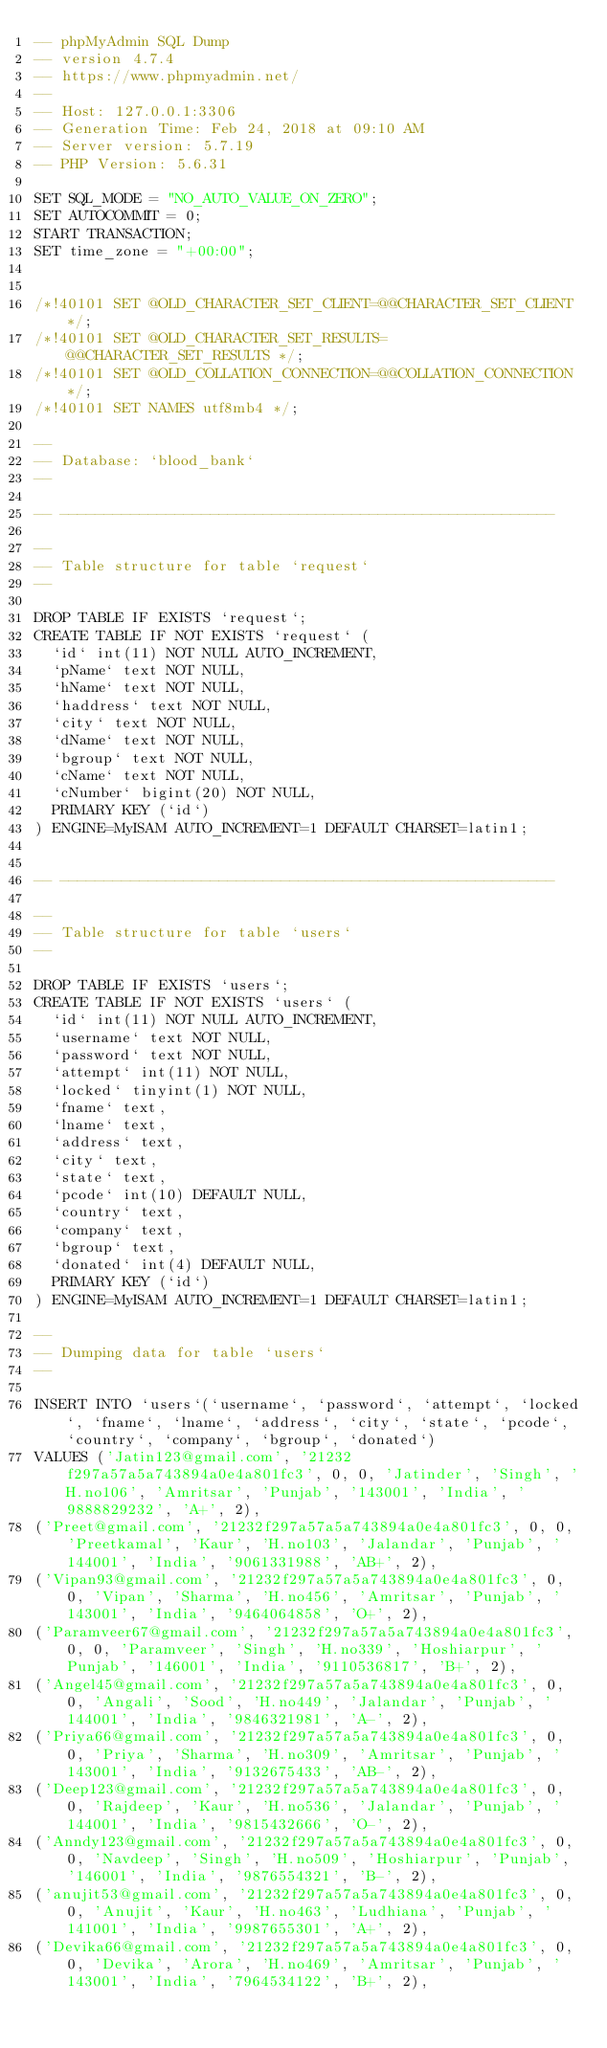<code> <loc_0><loc_0><loc_500><loc_500><_SQL_>-- phpMyAdmin SQL Dump
-- version 4.7.4
-- https://www.phpmyadmin.net/
--
-- Host: 127.0.0.1:3306
-- Generation Time: Feb 24, 2018 at 09:10 AM
-- Server version: 5.7.19
-- PHP Version: 5.6.31

SET SQL_MODE = "NO_AUTO_VALUE_ON_ZERO";
SET AUTOCOMMIT = 0;
START TRANSACTION;
SET time_zone = "+00:00";


/*!40101 SET @OLD_CHARACTER_SET_CLIENT=@@CHARACTER_SET_CLIENT */;
/*!40101 SET @OLD_CHARACTER_SET_RESULTS=@@CHARACTER_SET_RESULTS */;
/*!40101 SET @OLD_COLLATION_CONNECTION=@@COLLATION_CONNECTION */;
/*!40101 SET NAMES utf8mb4 */;

--
-- Database: `blood_bank`
--

-- --------------------------------------------------------

--
-- Table structure for table `request`
--

DROP TABLE IF EXISTS `request`;
CREATE TABLE IF NOT EXISTS `request` (
  `id` int(11) NOT NULL AUTO_INCREMENT,
  `pName` text NOT NULL,
  `hName` text NOT NULL,
  `haddress` text NOT NULL,
  `city` text NOT NULL,
  `dName` text NOT NULL,
  `bgroup` text NOT NULL,
  `cName` text NOT NULL,
  `cNumber` bigint(20) NOT NULL,
  PRIMARY KEY (`id`)
) ENGINE=MyISAM AUTO_INCREMENT=1 DEFAULT CHARSET=latin1;


-- --------------------------------------------------------

--
-- Table structure for table `users`
--

DROP TABLE IF EXISTS `users`;
CREATE TABLE IF NOT EXISTS `users` (
  `id` int(11) NOT NULL AUTO_INCREMENT,
  `username` text NOT NULL,
  `password` text NOT NULL,
  `attempt` int(11) NOT NULL,
  `locked` tinyint(1) NOT NULL,
  `fname` text,
  `lname` text,
  `address` text,
  `city` text,
  `state` text,
  `pcode` int(10) DEFAULT NULL,
  `country` text,
  `company` text,
  `bgroup` text,
  `donated` int(4) DEFAULT NULL,
  PRIMARY KEY (`id`)
) ENGINE=MyISAM AUTO_INCREMENT=1 DEFAULT CHARSET=latin1;

--
-- Dumping data for table `users`
--

INSERT INTO `users`(`username`, `password`, `attempt`, `locked`, `fname`, `lname`, `address`, `city`, `state`, `pcode`, `country`, `company`, `bgroup`, `donated`) 
VALUES ('Jatin123@gmail.com', '21232f297a57a5a743894a0e4a801fc3', 0, 0, 'Jatinder', 'Singh', 'H.no106', 'Amritsar', 'Punjab', '143001', 'India', '9888829232', 'A+', 2),
('Preet@gmail.com', '21232f297a57a5a743894a0e4a801fc3', 0, 0, 'Preetkamal', 'Kaur', 'H.no103', 'Jalandar', 'Punjab', '144001', 'India', '9061331988', 'AB+', 2),
('Vipan93@gmail.com', '21232f297a57a5a743894a0e4a801fc3', 0, 0, 'Vipan', 'Sharma', 'H.no456', 'Amritsar', 'Punjab', '143001', 'India', '9464064858', 'O+', 2),
('Paramveer67@gmail.com', '21232f297a57a5a743894a0e4a801fc3', 0, 0, 'Paramveer', 'Singh', 'H.no339', 'Hoshiarpur', 'Punjab', '146001', 'India', '9110536817', 'B+', 2),
('Angel45@gmail.com', '21232f297a57a5a743894a0e4a801fc3', 0, 0, 'Angali', 'Sood', 'H.no449', 'Jalandar', 'Punjab', '144001', 'India', '9846321981', 'A-', 2),
('Priya66@gmail.com', '21232f297a57a5a743894a0e4a801fc3', 0, 0, 'Priya', 'Sharma', 'H.no309', 'Amritsar', 'Punjab', '143001', 'India', '9132675433', 'AB-', 2),
('Deep123@gmail.com', '21232f297a57a5a743894a0e4a801fc3', 0, 0, 'Rajdeep', 'Kaur', 'H.no536', 'Jalandar', 'Punjab', '144001', 'India', '9815432666', 'O-', 2),
('Anndy123@gmail.com', '21232f297a57a5a743894a0e4a801fc3', 0, 0, 'Navdeep', 'Singh', 'H.no509', 'Hoshiarpur', 'Punjab', '146001', 'India', '9876554321', 'B-', 2),
('anujit53@gmail.com', '21232f297a57a5a743894a0e4a801fc3', 0, 0, 'Anujit', 'Kaur', 'H.no463', 'Ludhiana', 'Punjab', '141001', 'India', '9987655301', 'A+', 2),
('Devika66@gmail.com', '21232f297a57a5a743894a0e4a801fc3', 0, 0, 'Devika', 'Arora', 'H.no469', 'Amritsar', 'Punjab', '143001', 'India', '7964534122', 'B+', 2),</code> 